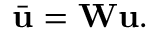Convert formula to latex. <formula><loc_0><loc_0><loc_500><loc_500>\bar { u } = W u .</formula> 